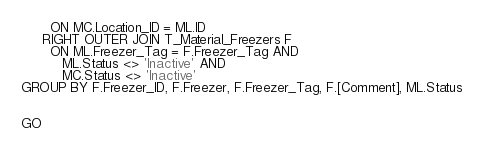<code> <loc_0><loc_0><loc_500><loc_500><_SQL_>       ON MC.Location_ID = ML.ID
     RIGHT OUTER JOIN T_Material_Freezers F
       ON ML.Freezer_Tag = F.Freezer_Tag AND
          ML.Status <> 'Inactive' AND
          MC.Status <> 'Inactive'
GROUP BY F.Freezer_ID, F.Freezer, F.Freezer_Tag, F.[Comment], ML.Status


GO
</code> 